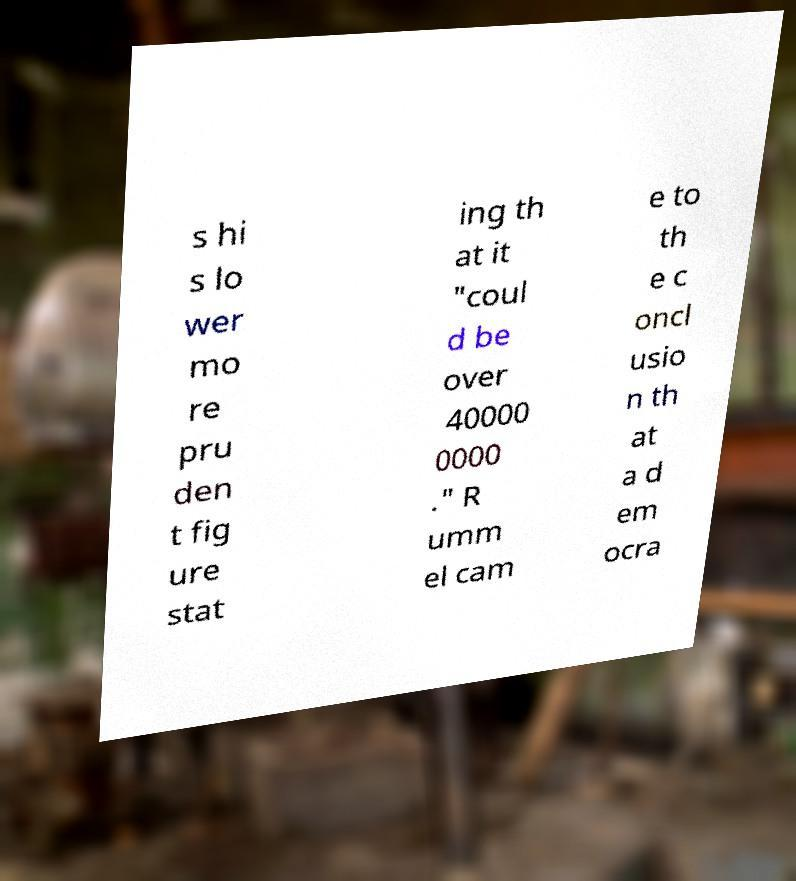I need the written content from this picture converted into text. Can you do that? s hi s lo wer mo re pru den t fig ure stat ing th at it "coul d be over 40000 0000 ." R umm el cam e to th e c oncl usio n th at a d em ocra 